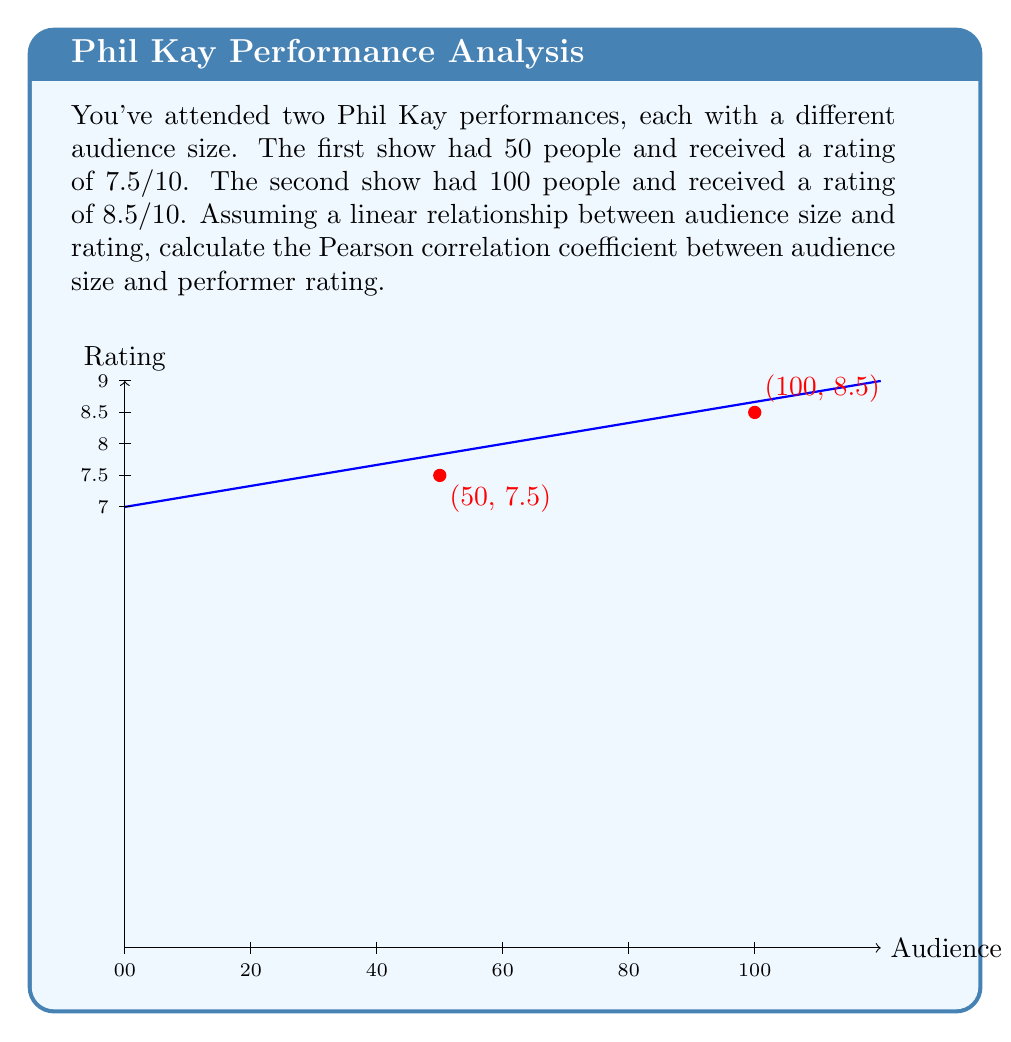Help me with this question. To calculate the Pearson correlation coefficient (r), we'll use the formula:

$$ r = \frac{\sum_{i=1}^{n} (x_i - \bar{x})(y_i - \bar{y})}{\sqrt{\sum_{i=1}^{n} (x_i - \bar{x})^2} \sqrt{\sum_{i=1}^{n} (y_i - \bar{y})^2}} $$

Where:
$x_i$ = audience size
$y_i$ = rating
$\bar{x}$ = mean audience size
$\bar{y}$ = mean rating

Step 1: Calculate means
$\bar{x} = \frac{50 + 100}{2} = 75$
$\bar{y} = \frac{7.5 + 8.5}{2} = 8$

Step 2: Calculate $(x_i - \bar{x})$ and $(y_i - \bar{y})$
$(x_1 - \bar{x}) = 50 - 75 = -25$
$(x_2 - \bar{x}) = 100 - 75 = 25$
$(y_1 - \bar{y}) = 7.5 - 8 = -0.5$
$(y_2 - \bar{y}) = 8.5 - 8 = 0.5$

Step 3: Calculate the numerator
$\sum_{i=1}^{n} (x_i - \bar{x})(y_i - \bar{y}) = (-25)(-0.5) + (25)(0.5) = 12.5 + 12.5 = 25$

Step 4: Calculate the denominator
$\sqrt{\sum_{i=1}^{n} (x_i - \bar{x})^2} = \sqrt{(-25)^2 + (25)^2} = \sqrt{1250} = 25\sqrt{2}$
$\sqrt{\sum_{i=1}^{n} (y_i - \bar{y})^2} = \sqrt{(-0.5)^2 + (0.5)^2} = \sqrt{0.5} = 0.5\sqrt{2}$

Step 5: Calculate r
$r = \frac{25}{25\sqrt{2} \cdot 0.5\sqrt{2}} = \frac{25}{25} = 1$
Answer: 1 